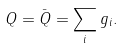Convert formula to latex. <formula><loc_0><loc_0><loc_500><loc_500>Q = \bar { Q } = \sum _ { i } g _ { i } .</formula> 